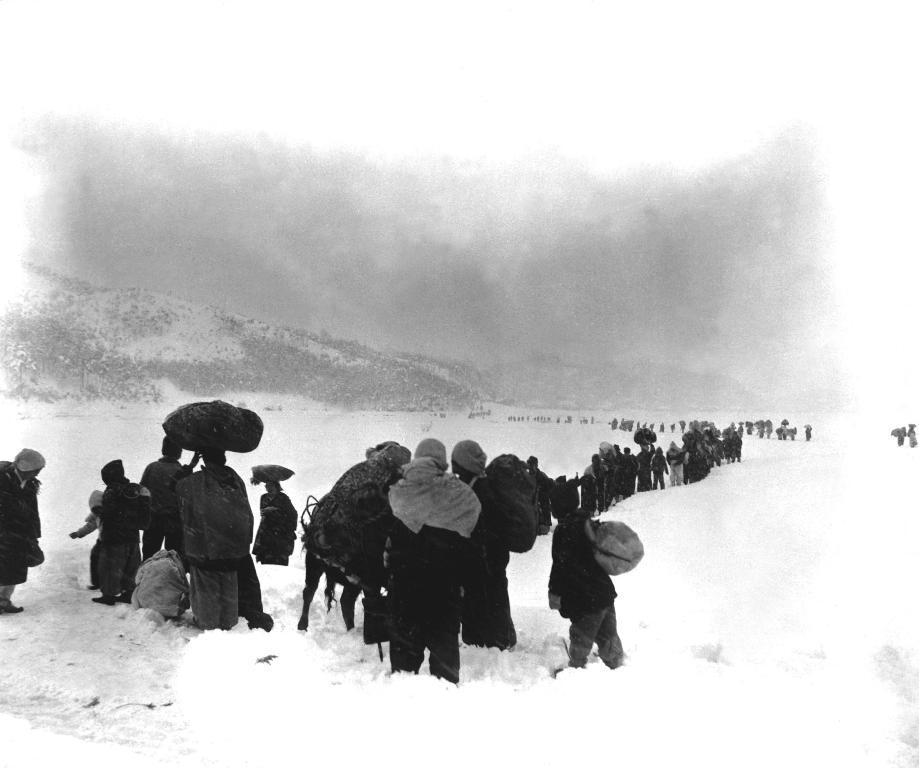Who or what is present in the image? There are people in the image. What is the ground made of at the bottom of the image? There is snow at the bottom of the image. What can be seen in the distance in the image? There are hills in the background of the image. What is visible in the sky in the image? The sky is visible in the background of the image. How many babies are wearing mittens in the image? There are no babies or mittens present in the image. What type of face can be seen on the hills in the background? There are no faces visible on the hills in the background; they are natural formations. 